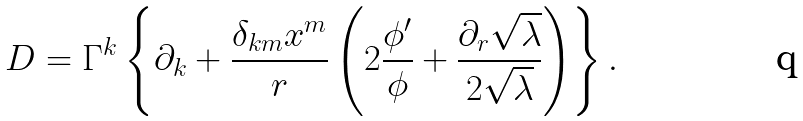<formula> <loc_0><loc_0><loc_500><loc_500>D = \Gamma ^ { k } \left \{ \partial _ { k } + \frac { \delta _ { k m } x ^ { m } } { r } \left ( 2 \frac { \phi ^ { \prime } } { \phi } + \frac { \partial _ { r } \sqrt { \lambda } } { 2 \sqrt { \lambda } } \right ) \right \} .</formula> 